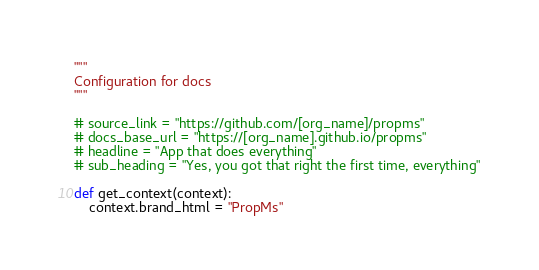<code> <loc_0><loc_0><loc_500><loc_500><_Python_>"""
Configuration for docs
"""

# source_link = "https://github.com/[org_name]/propms"
# docs_base_url = "https://[org_name].github.io/propms"
# headline = "App that does everything"
# sub_heading = "Yes, you got that right the first time, everything"

def get_context(context):
	context.brand_html = "PropMs"
</code> 